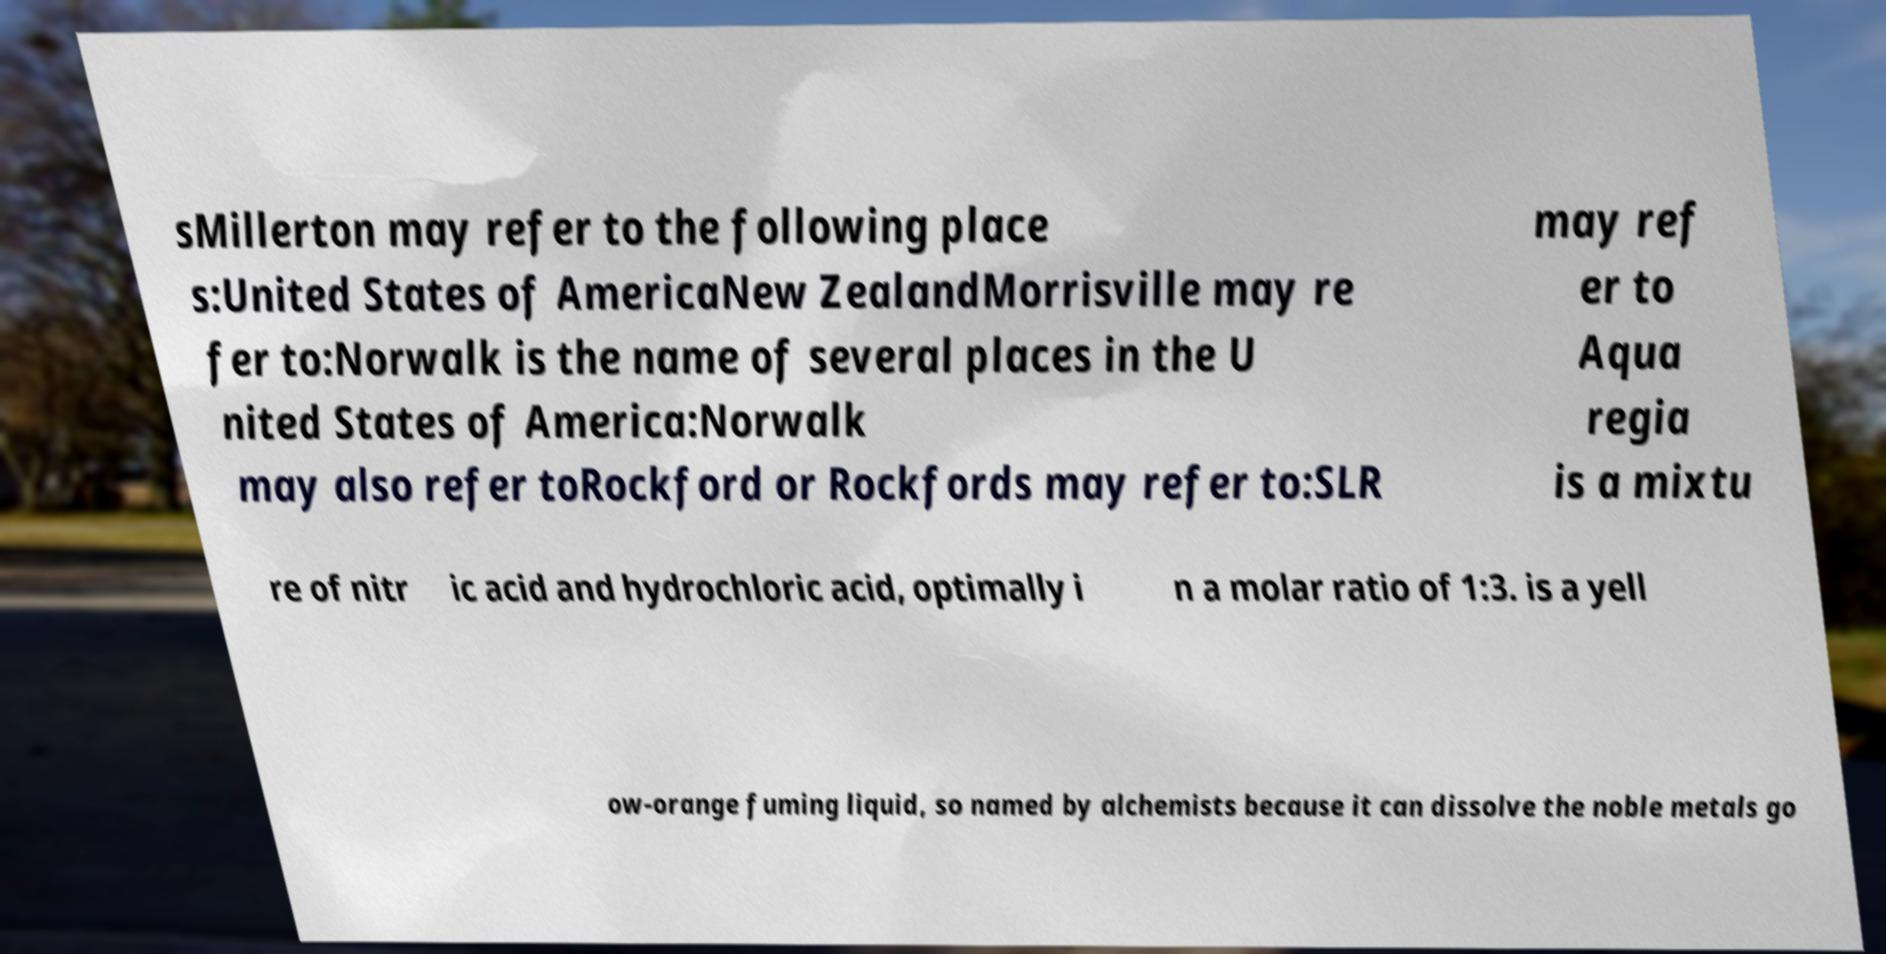For documentation purposes, I need the text within this image transcribed. Could you provide that? sMillerton may refer to the following place s:United States of AmericaNew ZealandMorrisville may re fer to:Norwalk is the name of several places in the U nited States of America:Norwalk may also refer toRockford or Rockfords may refer to:SLR may ref er to Aqua regia is a mixtu re of nitr ic acid and hydrochloric acid, optimally i n a molar ratio of 1:3. is a yell ow-orange fuming liquid, so named by alchemists because it can dissolve the noble metals go 